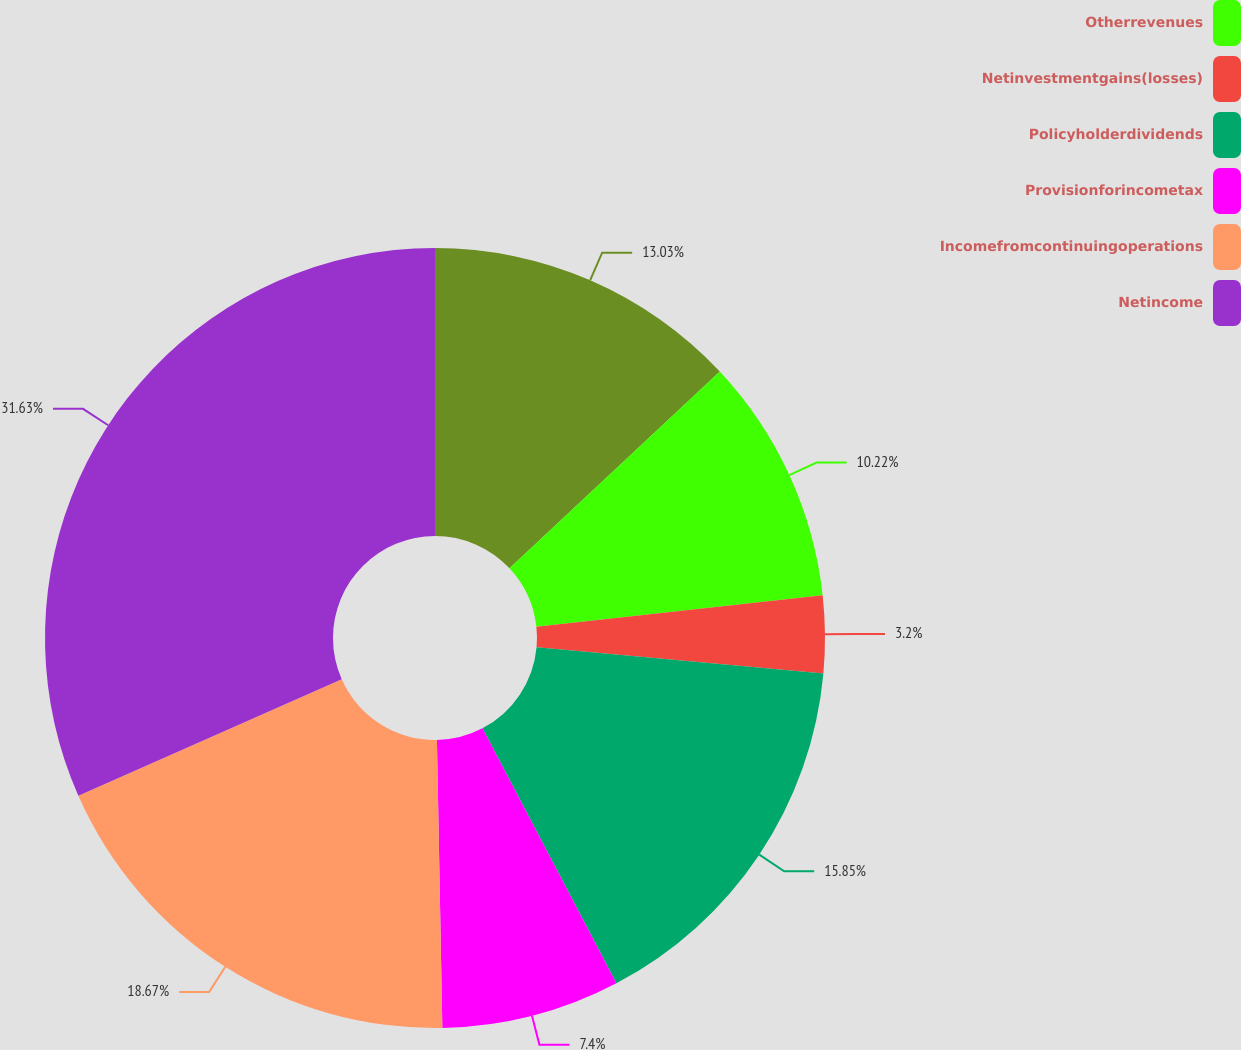Convert chart. <chart><loc_0><loc_0><loc_500><loc_500><pie_chart><ecel><fcel>Otherrevenues<fcel>Netinvestmentgains(losses)<fcel>Policyholderdividends<fcel>Provisionforincometax<fcel>Incomefromcontinuingoperations<fcel>Netincome<nl><fcel>13.03%<fcel>10.22%<fcel>3.2%<fcel>15.85%<fcel>7.4%<fcel>18.67%<fcel>31.63%<nl></chart> 